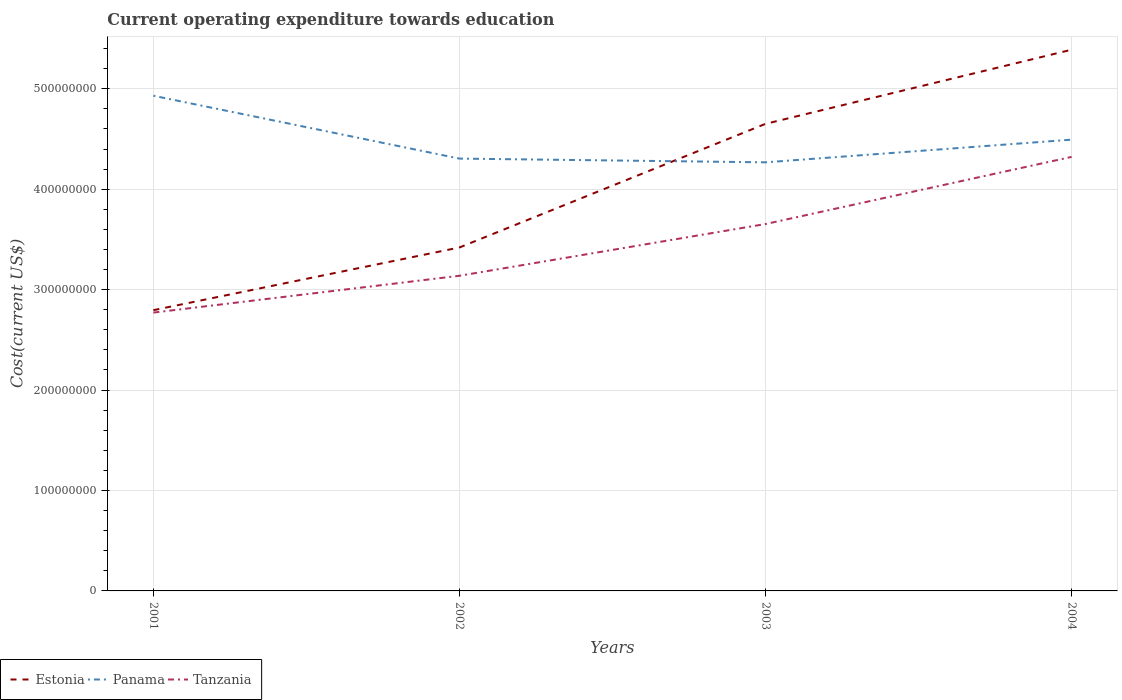How many different coloured lines are there?
Offer a terse response. 3. Does the line corresponding to Estonia intersect with the line corresponding to Panama?
Ensure brevity in your answer.  Yes. Across all years, what is the maximum expenditure towards education in Estonia?
Your answer should be very brief. 2.80e+08. In which year was the expenditure towards education in Tanzania maximum?
Make the answer very short. 2001. What is the total expenditure towards education in Tanzania in the graph?
Keep it short and to the point. -1.55e+08. What is the difference between the highest and the second highest expenditure towards education in Panama?
Give a very brief answer. 6.63e+07. What is the difference between the highest and the lowest expenditure towards education in Tanzania?
Your answer should be compact. 2. How many lines are there?
Keep it short and to the point. 3. Are the values on the major ticks of Y-axis written in scientific E-notation?
Make the answer very short. No. Does the graph contain any zero values?
Your answer should be very brief. No. How many legend labels are there?
Provide a succinct answer. 3. How are the legend labels stacked?
Your answer should be compact. Horizontal. What is the title of the graph?
Give a very brief answer. Current operating expenditure towards education. What is the label or title of the X-axis?
Keep it short and to the point. Years. What is the label or title of the Y-axis?
Your response must be concise. Cost(current US$). What is the Cost(current US$) in Estonia in 2001?
Your answer should be very brief. 2.80e+08. What is the Cost(current US$) in Panama in 2001?
Your answer should be compact. 4.93e+08. What is the Cost(current US$) in Tanzania in 2001?
Your answer should be very brief. 2.77e+08. What is the Cost(current US$) of Estonia in 2002?
Offer a very short reply. 3.42e+08. What is the Cost(current US$) of Panama in 2002?
Keep it short and to the point. 4.30e+08. What is the Cost(current US$) of Tanzania in 2002?
Offer a terse response. 3.14e+08. What is the Cost(current US$) in Estonia in 2003?
Keep it short and to the point. 4.65e+08. What is the Cost(current US$) in Panama in 2003?
Your answer should be compact. 4.27e+08. What is the Cost(current US$) in Tanzania in 2003?
Provide a short and direct response. 3.65e+08. What is the Cost(current US$) of Estonia in 2004?
Provide a succinct answer. 5.39e+08. What is the Cost(current US$) of Panama in 2004?
Keep it short and to the point. 4.49e+08. What is the Cost(current US$) in Tanzania in 2004?
Ensure brevity in your answer.  4.32e+08. Across all years, what is the maximum Cost(current US$) in Estonia?
Offer a very short reply. 5.39e+08. Across all years, what is the maximum Cost(current US$) in Panama?
Your answer should be very brief. 4.93e+08. Across all years, what is the maximum Cost(current US$) in Tanzania?
Give a very brief answer. 4.32e+08. Across all years, what is the minimum Cost(current US$) of Estonia?
Provide a succinct answer. 2.80e+08. Across all years, what is the minimum Cost(current US$) of Panama?
Your response must be concise. 4.27e+08. Across all years, what is the minimum Cost(current US$) of Tanzania?
Offer a very short reply. 2.77e+08. What is the total Cost(current US$) in Estonia in the graph?
Your answer should be compact. 1.63e+09. What is the total Cost(current US$) in Panama in the graph?
Offer a terse response. 1.80e+09. What is the total Cost(current US$) in Tanzania in the graph?
Provide a succinct answer. 1.39e+09. What is the difference between the Cost(current US$) of Estonia in 2001 and that in 2002?
Provide a short and direct response. -6.24e+07. What is the difference between the Cost(current US$) in Panama in 2001 and that in 2002?
Ensure brevity in your answer.  6.26e+07. What is the difference between the Cost(current US$) in Tanzania in 2001 and that in 2002?
Your response must be concise. -3.67e+07. What is the difference between the Cost(current US$) of Estonia in 2001 and that in 2003?
Keep it short and to the point. -1.86e+08. What is the difference between the Cost(current US$) of Panama in 2001 and that in 2003?
Your answer should be very brief. 6.63e+07. What is the difference between the Cost(current US$) of Tanzania in 2001 and that in 2003?
Give a very brief answer. -8.82e+07. What is the difference between the Cost(current US$) in Estonia in 2001 and that in 2004?
Offer a terse response. -2.59e+08. What is the difference between the Cost(current US$) in Panama in 2001 and that in 2004?
Your answer should be very brief. 4.37e+07. What is the difference between the Cost(current US$) in Tanzania in 2001 and that in 2004?
Provide a short and direct response. -1.55e+08. What is the difference between the Cost(current US$) in Estonia in 2002 and that in 2003?
Ensure brevity in your answer.  -1.23e+08. What is the difference between the Cost(current US$) of Panama in 2002 and that in 2003?
Offer a terse response. 3.71e+06. What is the difference between the Cost(current US$) in Tanzania in 2002 and that in 2003?
Keep it short and to the point. -5.15e+07. What is the difference between the Cost(current US$) in Estonia in 2002 and that in 2004?
Offer a very short reply. -1.97e+08. What is the difference between the Cost(current US$) in Panama in 2002 and that in 2004?
Give a very brief answer. -1.89e+07. What is the difference between the Cost(current US$) in Tanzania in 2002 and that in 2004?
Your answer should be very brief. -1.18e+08. What is the difference between the Cost(current US$) in Estonia in 2003 and that in 2004?
Offer a very short reply. -7.38e+07. What is the difference between the Cost(current US$) in Panama in 2003 and that in 2004?
Your answer should be very brief. -2.26e+07. What is the difference between the Cost(current US$) of Tanzania in 2003 and that in 2004?
Offer a terse response. -6.68e+07. What is the difference between the Cost(current US$) of Estonia in 2001 and the Cost(current US$) of Panama in 2002?
Provide a short and direct response. -1.51e+08. What is the difference between the Cost(current US$) in Estonia in 2001 and the Cost(current US$) in Tanzania in 2002?
Provide a succinct answer. -3.42e+07. What is the difference between the Cost(current US$) of Panama in 2001 and the Cost(current US$) of Tanzania in 2002?
Provide a succinct answer. 1.79e+08. What is the difference between the Cost(current US$) in Estonia in 2001 and the Cost(current US$) in Panama in 2003?
Make the answer very short. -1.47e+08. What is the difference between the Cost(current US$) of Estonia in 2001 and the Cost(current US$) of Tanzania in 2003?
Ensure brevity in your answer.  -8.58e+07. What is the difference between the Cost(current US$) in Panama in 2001 and the Cost(current US$) in Tanzania in 2003?
Keep it short and to the point. 1.28e+08. What is the difference between the Cost(current US$) of Estonia in 2001 and the Cost(current US$) of Panama in 2004?
Your answer should be compact. -1.70e+08. What is the difference between the Cost(current US$) in Estonia in 2001 and the Cost(current US$) in Tanzania in 2004?
Keep it short and to the point. -1.53e+08. What is the difference between the Cost(current US$) of Panama in 2001 and the Cost(current US$) of Tanzania in 2004?
Give a very brief answer. 6.09e+07. What is the difference between the Cost(current US$) in Estonia in 2002 and the Cost(current US$) in Panama in 2003?
Provide a succinct answer. -8.48e+07. What is the difference between the Cost(current US$) in Estonia in 2002 and the Cost(current US$) in Tanzania in 2003?
Keep it short and to the point. -2.34e+07. What is the difference between the Cost(current US$) in Panama in 2002 and the Cost(current US$) in Tanzania in 2003?
Provide a succinct answer. 6.51e+07. What is the difference between the Cost(current US$) in Estonia in 2002 and the Cost(current US$) in Panama in 2004?
Ensure brevity in your answer.  -1.07e+08. What is the difference between the Cost(current US$) in Estonia in 2002 and the Cost(current US$) in Tanzania in 2004?
Your answer should be very brief. -9.02e+07. What is the difference between the Cost(current US$) of Panama in 2002 and the Cost(current US$) of Tanzania in 2004?
Make the answer very short. -1.69e+06. What is the difference between the Cost(current US$) of Estonia in 2003 and the Cost(current US$) of Panama in 2004?
Provide a short and direct response. 1.57e+07. What is the difference between the Cost(current US$) of Estonia in 2003 and the Cost(current US$) of Tanzania in 2004?
Make the answer very short. 3.29e+07. What is the difference between the Cost(current US$) of Panama in 2003 and the Cost(current US$) of Tanzania in 2004?
Your response must be concise. -5.41e+06. What is the average Cost(current US$) of Estonia per year?
Your response must be concise. 4.06e+08. What is the average Cost(current US$) in Panama per year?
Ensure brevity in your answer.  4.50e+08. What is the average Cost(current US$) of Tanzania per year?
Keep it short and to the point. 3.47e+08. In the year 2001, what is the difference between the Cost(current US$) of Estonia and Cost(current US$) of Panama?
Make the answer very short. -2.13e+08. In the year 2001, what is the difference between the Cost(current US$) in Estonia and Cost(current US$) in Tanzania?
Provide a succinct answer. 2.40e+06. In the year 2001, what is the difference between the Cost(current US$) in Panama and Cost(current US$) in Tanzania?
Offer a very short reply. 2.16e+08. In the year 2002, what is the difference between the Cost(current US$) of Estonia and Cost(current US$) of Panama?
Your response must be concise. -8.85e+07. In the year 2002, what is the difference between the Cost(current US$) in Estonia and Cost(current US$) in Tanzania?
Provide a succinct answer. 2.82e+07. In the year 2002, what is the difference between the Cost(current US$) in Panama and Cost(current US$) in Tanzania?
Provide a short and direct response. 1.17e+08. In the year 2003, what is the difference between the Cost(current US$) in Estonia and Cost(current US$) in Panama?
Your answer should be compact. 3.83e+07. In the year 2003, what is the difference between the Cost(current US$) of Estonia and Cost(current US$) of Tanzania?
Ensure brevity in your answer.  9.98e+07. In the year 2003, what is the difference between the Cost(current US$) in Panama and Cost(current US$) in Tanzania?
Your response must be concise. 6.14e+07. In the year 2004, what is the difference between the Cost(current US$) in Estonia and Cost(current US$) in Panama?
Provide a short and direct response. 8.95e+07. In the year 2004, what is the difference between the Cost(current US$) of Estonia and Cost(current US$) of Tanzania?
Give a very brief answer. 1.07e+08. In the year 2004, what is the difference between the Cost(current US$) in Panama and Cost(current US$) in Tanzania?
Give a very brief answer. 1.72e+07. What is the ratio of the Cost(current US$) in Estonia in 2001 to that in 2002?
Provide a short and direct response. 0.82. What is the ratio of the Cost(current US$) in Panama in 2001 to that in 2002?
Your response must be concise. 1.15. What is the ratio of the Cost(current US$) of Tanzania in 2001 to that in 2002?
Keep it short and to the point. 0.88. What is the ratio of the Cost(current US$) in Estonia in 2001 to that in 2003?
Ensure brevity in your answer.  0.6. What is the ratio of the Cost(current US$) in Panama in 2001 to that in 2003?
Keep it short and to the point. 1.16. What is the ratio of the Cost(current US$) of Tanzania in 2001 to that in 2003?
Offer a terse response. 0.76. What is the ratio of the Cost(current US$) of Estonia in 2001 to that in 2004?
Make the answer very short. 0.52. What is the ratio of the Cost(current US$) in Panama in 2001 to that in 2004?
Provide a short and direct response. 1.1. What is the ratio of the Cost(current US$) of Tanzania in 2001 to that in 2004?
Provide a succinct answer. 0.64. What is the ratio of the Cost(current US$) in Estonia in 2002 to that in 2003?
Provide a succinct answer. 0.74. What is the ratio of the Cost(current US$) in Panama in 2002 to that in 2003?
Keep it short and to the point. 1.01. What is the ratio of the Cost(current US$) of Tanzania in 2002 to that in 2003?
Provide a short and direct response. 0.86. What is the ratio of the Cost(current US$) in Estonia in 2002 to that in 2004?
Your response must be concise. 0.63. What is the ratio of the Cost(current US$) in Panama in 2002 to that in 2004?
Offer a very short reply. 0.96. What is the ratio of the Cost(current US$) in Tanzania in 2002 to that in 2004?
Your answer should be compact. 0.73. What is the ratio of the Cost(current US$) of Estonia in 2003 to that in 2004?
Make the answer very short. 0.86. What is the ratio of the Cost(current US$) in Panama in 2003 to that in 2004?
Your answer should be very brief. 0.95. What is the ratio of the Cost(current US$) of Tanzania in 2003 to that in 2004?
Offer a very short reply. 0.85. What is the difference between the highest and the second highest Cost(current US$) of Estonia?
Make the answer very short. 7.38e+07. What is the difference between the highest and the second highest Cost(current US$) of Panama?
Your response must be concise. 4.37e+07. What is the difference between the highest and the second highest Cost(current US$) of Tanzania?
Provide a succinct answer. 6.68e+07. What is the difference between the highest and the lowest Cost(current US$) in Estonia?
Give a very brief answer. 2.59e+08. What is the difference between the highest and the lowest Cost(current US$) in Panama?
Your answer should be compact. 6.63e+07. What is the difference between the highest and the lowest Cost(current US$) in Tanzania?
Offer a very short reply. 1.55e+08. 